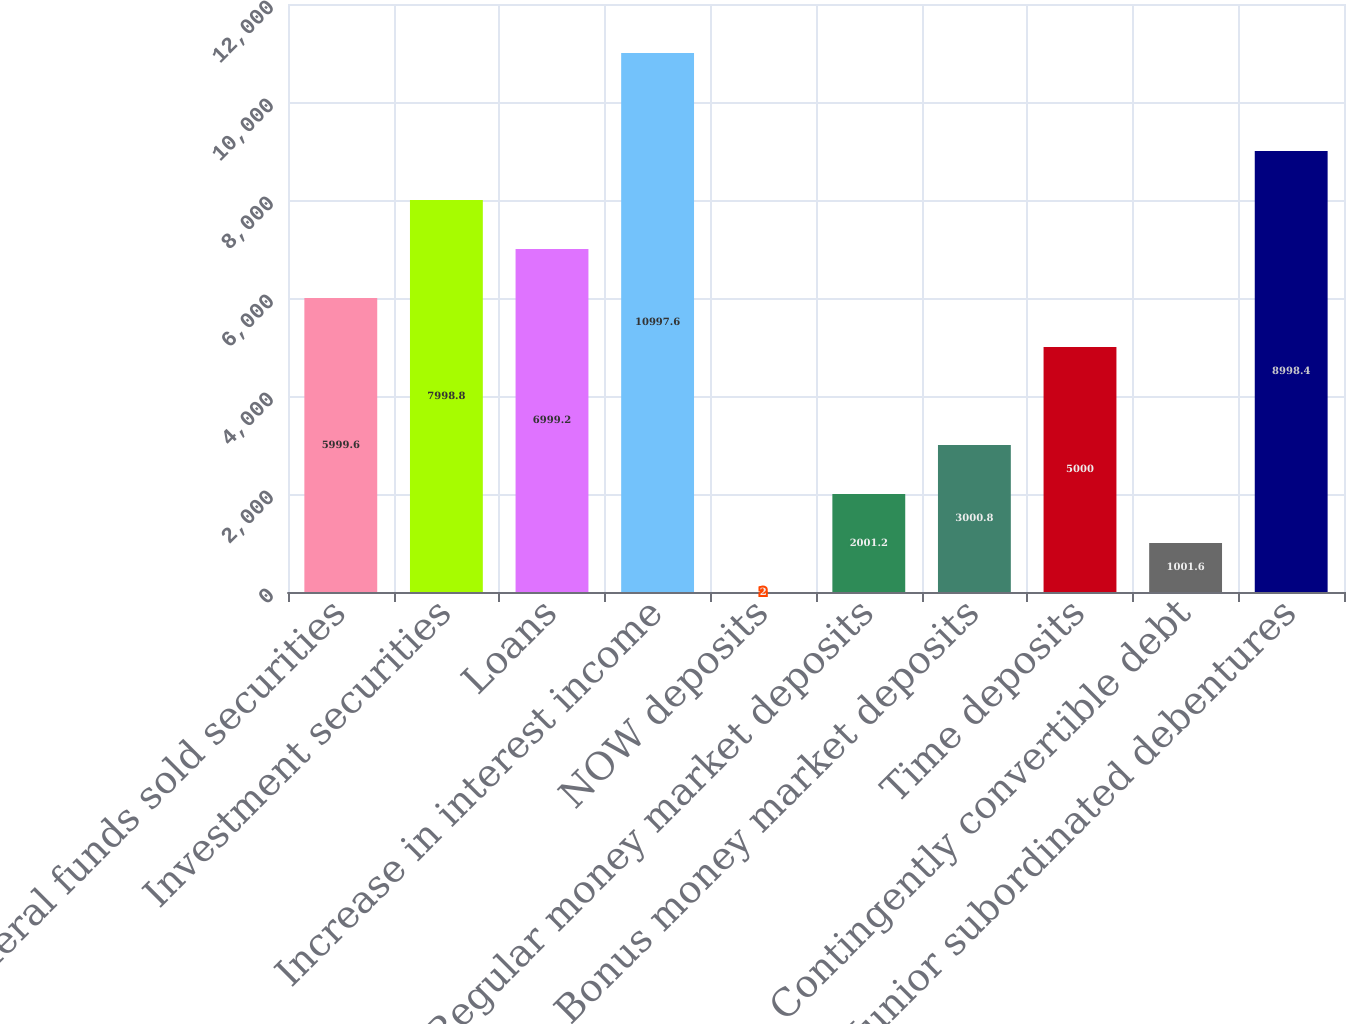Convert chart to OTSL. <chart><loc_0><loc_0><loc_500><loc_500><bar_chart><fcel>Federal funds sold securities<fcel>Investment securities<fcel>Loans<fcel>Increase in interest income<fcel>NOW deposits<fcel>Regular money market deposits<fcel>Bonus money market deposits<fcel>Time deposits<fcel>Contingently convertible debt<fcel>Junior subordinated debentures<nl><fcel>5999.6<fcel>7998.8<fcel>6999.2<fcel>10997.6<fcel>2<fcel>2001.2<fcel>3000.8<fcel>5000<fcel>1001.6<fcel>8998.4<nl></chart> 